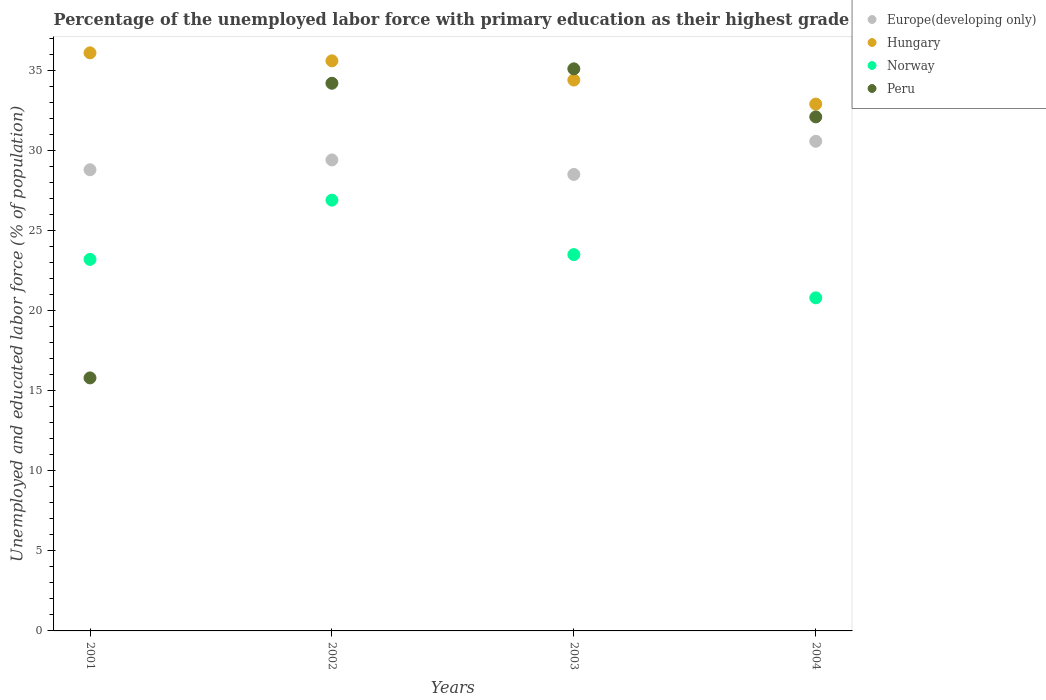What is the percentage of the unemployed labor force with primary education in Peru in 2001?
Make the answer very short. 15.8. Across all years, what is the maximum percentage of the unemployed labor force with primary education in Peru?
Offer a terse response. 35.1. Across all years, what is the minimum percentage of the unemployed labor force with primary education in Norway?
Ensure brevity in your answer.  20.8. In which year was the percentage of the unemployed labor force with primary education in Hungary maximum?
Provide a succinct answer. 2001. In which year was the percentage of the unemployed labor force with primary education in Hungary minimum?
Provide a succinct answer. 2004. What is the total percentage of the unemployed labor force with primary education in Norway in the graph?
Your response must be concise. 94.4. What is the difference between the percentage of the unemployed labor force with primary education in Europe(developing only) in 2001 and that in 2002?
Offer a very short reply. -0.61. What is the difference between the percentage of the unemployed labor force with primary education in Hungary in 2002 and the percentage of the unemployed labor force with primary education in Peru in 2003?
Ensure brevity in your answer.  0.5. What is the average percentage of the unemployed labor force with primary education in Peru per year?
Offer a terse response. 29.3. In the year 2004, what is the difference between the percentage of the unemployed labor force with primary education in Norway and percentage of the unemployed labor force with primary education in Peru?
Your response must be concise. -11.3. What is the ratio of the percentage of the unemployed labor force with primary education in Europe(developing only) in 2001 to that in 2003?
Give a very brief answer. 1.01. What is the difference between the highest and the second highest percentage of the unemployed labor force with primary education in Peru?
Your answer should be very brief. 0.9. What is the difference between the highest and the lowest percentage of the unemployed labor force with primary education in Europe(developing only)?
Offer a terse response. 2.07. Is the sum of the percentage of the unemployed labor force with primary education in Hungary in 2001 and 2003 greater than the maximum percentage of the unemployed labor force with primary education in Peru across all years?
Offer a terse response. Yes. Does the percentage of the unemployed labor force with primary education in Europe(developing only) monotonically increase over the years?
Make the answer very short. No. Is the percentage of the unemployed labor force with primary education in Norway strictly greater than the percentage of the unemployed labor force with primary education in Hungary over the years?
Ensure brevity in your answer.  No. Is the percentage of the unemployed labor force with primary education in Europe(developing only) strictly less than the percentage of the unemployed labor force with primary education in Hungary over the years?
Give a very brief answer. Yes. How many dotlines are there?
Provide a succinct answer. 4. What is the difference between two consecutive major ticks on the Y-axis?
Your response must be concise. 5. Does the graph contain grids?
Your response must be concise. No. How many legend labels are there?
Your answer should be very brief. 4. What is the title of the graph?
Your response must be concise. Percentage of the unemployed labor force with primary education as their highest grade. What is the label or title of the X-axis?
Provide a short and direct response. Years. What is the label or title of the Y-axis?
Your answer should be very brief. Unemployed and educated labor force (% of population). What is the Unemployed and educated labor force (% of population) in Europe(developing only) in 2001?
Offer a terse response. 28.8. What is the Unemployed and educated labor force (% of population) of Hungary in 2001?
Ensure brevity in your answer.  36.1. What is the Unemployed and educated labor force (% of population) in Norway in 2001?
Offer a very short reply. 23.2. What is the Unemployed and educated labor force (% of population) in Peru in 2001?
Give a very brief answer. 15.8. What is the Unemployed and educated labor force (% of population) of Europe(developing only) in 2002?
Provide a succinct answer. 29.41. What is the Unemployed and educated labor force (% of population) of Hungary in 2002?
Provide a succinct answer. 35.6. What is the Unemployed and educated labor force (% of population) in Norway in 2002?
Keep it short and to the point. 26.9. What is the Unemployed and educated labor force (% of population) in Peru in 2002?
Offer a very short reply. 34.2. What is the Unemployed and educated labor force (% of population) in Europe(developing only) in 2003?
Keep it short and to the point. 28.51. What is the Unemployed and educated labor force (% of population) of Hungary in 2003?
Keep it short and to the point. 34.4. What is the Unemployed and educated labor force (% of population) in Norway in 2003?
Provide a succinct answer. 23.5. What is the Unemployed and educated labor force (% of population) of Peru in 2003?
Offer a terse response. 35.1. What is the Unemployed and educated labor force (% of population) in Europe(developing only) in 2004?
Make the answer very short. 30.58. What is the Unemployed and educated labor force (% of population) in Hungary in 2004?
Your answer should be very brief. 32.9. What is the Unemployed and educated labor force (% of population) in Norway in 2004?
Ensure brevity in your answer.  20.8. What is the Unemployed and educated labor force (% of population) of Peru in 2004?
Give a very brief answer. 32.1. Across all years, what is the maximum Unemployed and educated labor force (% of population) in Europe(developing only)?
Offer a very short reply. 30.58. Across all years, what is the maximum Unemployed and educated labor force (% of population) of Hungary?
Ensure brevity in your answer.  36.1. Across all years, what is the maximum Unemployed and educated labor force (% of population) in Norway?
Your answer should be compact. 26.9. Across all years, what is the maximum Unemployed and educated labor force (% of population) in Peru?
Offer a very short reply. 35.1. Across all years, what is the minimum Unemployed and educated labor force (% of population) in Europe(developing only)?
Your answer should be very brief. 28.51. Across all years, what is the minimum Unemployed and educated labor force (% of population) of Hungary?
Offer a very short reply. 32.9. Across all years, what is the minimum Unemployed and educated labor force (% of population) in Norway?
Ensure brevity in your answer.  20.8. Across all years, what is the minimum Unemployed and educated labor force (% of population) of Peru?
Your response must be concise. 15.8. What is the total Unemployed and educated labor force (% of population) of Europe(developing only) in the graph?
Your response must be concise. 117.29. What is the total Unemployed and educated labor force (% of population) in Hungary in the graph?
Provide a succinct answer. 139. What is the total Unemployed and educated labor force (% of population) of Norway in the graph?
Offer a very short reply. 94.4. What is the total Unemployed and educated labor force (% of population) of Peru in the graph?
Give a very brief answer. 117.2. What is the difference between the Unemployed and educated labor force (% of population) in Europe(developing only) in 2001 and that in 2002?
Provide a succinct answer. -0.61. What is the difference between the Unemployed and educated labor force (% of population) of Hungary in 2001 and that in 2002?
Your response must be concise. 0.5. What is the difference between the Unemployed and educated labor force (% of population) in Norway in 2001 and that in 2002?
Keep it short and to the point. -3.7. What is the difference between the Unemployed and educated labor force (% of population) of Peru in 2001 and that in 2002?
Make the answer very short. -18.4. What is the difference between the Unemployed and educated labor force (% of population) of Europe(developing only) in 2001 and that in 2003?
Your answer should be very brief. 0.29. What is the difference between the Unemployed and educated labor force (% of population) of Hungary in 2001 and that in 2003?
Keep it short and to the point. 1.7. What is the difference between the Unemployed and educated labor force (% of population) of Peru in 2001 and that in 2003?
Offer a terse response. -19.3. What is the difference between the Unemployed and educated labor force (% of population) in Europe(developing only) in 2001 and that in 2004?
Your answer should be compact. -1.78. What is the difference between the Unemployed and educated labor force (% of population) of Hungary in 2001 and that in 2004?
Provide a short and direct response. 3.2. What is the difference between the Unemployed and educated labor force (% of population) of Norway in 2001 and that in 2004?
Your response must be concise. 2.4. What is the difference between the Unemployed and educated labor force (% of population) of Peru in 2001 and that in 2004?
Give a very brief answer. -16.3. What is the difference between the Unemployed and educated labor force (% of population) of Europe(developing only) in 2002 and that in 2003?
Provide a short and direct response. 0.91. What is the difference between the Unemployed and educated labor force (% of population) of Norway in 2002 and that in 2003?
Provide a succinct answer. 3.4. What is the difference between the Unemployed and educated labor force (% of population) in Europe(developing only) in 2002 and that in 2004?
Keep it short and to the point. -1.16. What is the difference between the Unemployed and educated labor force (% of population) of Hungary in 2002 and that in 2004?
Provide a short and direct response. 2.7. What is the difference between the Unemployed and educated labor force (% of population) in Norway in 2002 and that in 2004?
Offer a terse response. 6.1. What is the difference between the Unemployed and educated labor force (% of population) in Peru in 2002 and that in 2004?
Offer a very short reply. 2.1. What is the difference between the Unemployed and educated labor force (% of population) in Europe(developing only) in 2003 and that in 2004?
Give a very brief answer. -2.07. What is the difference between the Unemployed and educated labor force (% of population) of Hungary in 2003 and that in 2004?
Give a very brief answer. 1.5. What is the difference between the Unemployed and educated labor force (% of population) of Peru in 2003 and that in 2004?
Keep it short and to the point. 3. What is the difference between the Unemployed and educated labor force (% of population) in Europe(developing only) in 2001 and the Unemployed and educated labor force (% of population) in Hungary in 2002?
Offer a very short reply. -6.8. What is the difference between the Unemployed and educated labor force (% of population) of Europe(developing only) in 2001 and the Unemployed and educated labor force (% of population) of Norway in 2002?
Ensure brevity in your answer.  1.9. What is the difference between the Unemployed and educated labor force (% of population) of Europe(developing only) in 2001 and the Unemployed and educated labor force (% of population) of Peru in 2002?
Make the answer very short. -5.4. What is the difference between the Unemployed and educated labor force (% of population) of Hungary in 2001 and the Unemployed and educated labor force (% of population) of Norway in 2002?
Keep it short and to the point. 9.2. What is the difference between the Unemployed and educated labor force (% of population) of Europe(developing only) in 2001 and the Unemployed and educated labor force (% of population) of Hungary in 2003?
Ensure brevity in your answer.  -5.6. What is the difference between the Unemployed and educated labor force (% of population) in Europe(developing only) in 2001 and the Unemployed and educated labor force (% of population) in Norway in 2003?
Keep it short and to the point. 5.3. What is the difference between the Unemployed and educated labor force (% of population) in Europe(developing only) in 2001 and the Unemployed and educated labor force (% of population) in Peru in 2003?
Your answer should be very brief. -6.3. What is the difference between the Unemployed and educated labor force (% of population) of Hungary in 2001 and the Unemployed and educated labor force (% of population) of Peru in 2003?
Make the answer very short. 1. What is the difference between the Unemployed and educated labor force (% of population) of Europe(developing only) in 2001 and the Unemployed and educated labor force (% of population) of Hungary in 2004?
Give a very brief answer. -4.1. What is the difference between the Unemployed and educated labor force (% of population) in Europe(developing only) in 2001 and the Unemployed and educated labor force (% of population) in Norway in 2004?
Keep it short and to the point. 8. What is the difference between the Unemployed and educated labor force (% of population) in Europe(developing only) in 2001 and the Unemployed and educated labor force (% of population) in Peru in 2004?
Your answer should be compact. -3.3. What is the difference between the Unemployed and educated labor force (% of population) in Norway in 2001 and the Unemployed and educated labor force (% of population) in Peru in 2004?
Your answer should be very brief. -8.9. What is the difference between the Unemployed and educated labor force (% of population) in Europe(developing only) in 2002 and the Unemployed and educated labor force (% of population) in Hungary in 2003?
Offer a terse response. -4.99. What is the difference between the Unemployed and educated labor force (% of population) in Europe(developing only) in 2002 and the Unemployed and educated labor force (% of population) in Norway in 2003?
Offer a very short reply. 5.91. What is the difference between the Unemployed and educated labor force (% of population) of Europe(developing only) in 2002 and the Unemployed and educated labor force (% of population) of Peru in 2003?
Provide a succinct answer. -5.69. What is the difference between the Unemployed and educated labor force (% of population) of Hungary in 2002 and the Unemployed and educated labor force (% of population) of Norway in 2003?
Your response must be concise. 12.1. What is the difference between the Unemployed and educated labor force (% of population) in Hungary in 2002 and the Unemployed and educated labor force (% of population) in Peru in 2003?
Provide a succinct answer. 0.5. What is the difference between the Unemployed and educated labor force (% of population) in Norway in 2002 and the Unemployed and educated labor force (% of population) in Peru in 2003?
Offer a terse response. -8.2. What is the difference between the Unemployed and educated labor force (% of population) of Europe(developing only) in 2002 and the Unemployed and educated labor force (% of population) of Hungary in 2004?
Your response must be concise. -3.49. What is the difference between the Unemployed and educated labor force (% of population) of Europe(developing only) in 2002 and the Unemployed and educated labor force (% of population) of Norway in 2004?
Your answer should be compact. 8.61. What is the difference between the Unemployed and educated labor force (% of population) in Europe(developing only) in 2002 and the Unemployed and educated labor force (% of population) in Peru in 2004?
Provide a succinct answer. -2.69. What is the difference between the Unemployed and educated labor force (% of population) of Hungary in 2002 and the Unemployed and educated labor force (% of population) of Peru in 2004?
Offer a very short reply. 3.5. What is the difference between the Unemployed and educated labor force (% of population) of Norway in 2002 and the Unemployed and educated labor force (% of population) of Peru in 2004?
Provide a succinct answer. -5.2. What is the difference between the Unemployed and educated labor force (% of population) of Europe(developing only) in 2003 and the Unemployed and educated labor force (% of population) of Hungary in 2004?
Make the answer very short. -4.39. What is the difference between the Unemployed and educated labor force (% of population) of Europe(developing only) in 2003 and the Unemployed and educated labor force (% of population) of Norway in 2004?
Keep it short and to the point. 7.71. What is the difference between the Unemployed and educated labor force (% of population) in Europe(developing only) in 2003 and the Unemployed and educated labor force (% of population) in Peru in 2004?
Keep it short and to the point. -3.59. What is the difference between the Unemployed and educated labor force (% of population) in Hungary in 2003 and the Unemployed and educated labor force (% of population) in Norway in 2004?
Offer a very short reply. 13.6. What is the average Unemployed and educated labor force (% of population) of Europe(developing only) per year?
Your answer should be compact. 29.32. What is the average Unemployed and educated labor force (% of population) of Hungary per year?
Ensure brevity in your answer.  34.75. What is the average Unemployed and educated labor force (% of population) of Norway per year?
Keep it short and to the point. 23.6. What is the average Unemployed and educated labor force (% of population) of Peru per year?
Give a very brief answer. 29.3. In the year 2001, what is the difference between the Unemployed and educated labor force (% of population) in Europe(developing only) and Unemployed and educated labor force (% of population) in Hungary?
Provide a succinct answer. -7.3. In the year 2001, what is the difference between the Unemployed and educated labor force (% of population) in Europe(developing only) and Unemployed and educated labor force (% of population) in Norway?
Offer a terse response. 5.6. In the year 2001, what is the difference between the Unemployed and educated labor force (% of population) of Europe(developing only) and Unemployed and educated labor force (% of population) of Peru?
Provide a short and direct response. 13. In the year 2001, what is the difference between the Unemployed and educated labor force (% of population) of Hungary and Unemployed and educated labor force (% of population) of Peru?
Provide a short and direct response. 20.3. In the year 2001, what is the difference between the Unemployed and educated labor force (% of population) of Norway and Unemployed and educated labor force (% of population) of Peru?
Provide a succinct answer. 7.4. In the year 2002, what is the difference between the Unemployed and educated labor force (% of population) of Europe(developing only) and Unemployed and educated labor force (% of population) of Hungary?
Provide a short and direct response. -6.19. In the year 2002, what is the difference between the Unemployed and educated labor force (% of population) of Europe(developing only) and Unemployed and educated labor force (% of population) of Norway?
Give a very brief answer. 2.51. In the year 2002, what is the difference between the Unemployed and educated labor force (% of population) in Europe(developing only) and Unemployed and educated labor force (% of population) in Peru?
Your answer should be compact. -4.79. In the year 2002, what is the difference between the Unemployed and educated labor force (% of population) in Hungary and Unemployed and educated labor force (% of population) in Peru?
Keep it short and to the point. 1.4. In the year 2002, what is the difference between the Unemployed and educated labor force (% of population) of Norway and Unemployed and educated labor force (% of population) of Peru?
Your response must be concise. -7.3. In the year 2003, what is the difference between the Unemployed and educated labor force (% of population) of Europe(developing only) and Unemployed and educated labor force (% of population) of Hungary?
Your response must be concise. -5.89. In the year 2003, what is the difference between the Unemployed and educated labor force (% of population) of Europe(developing only) and Unemployed and educated labor force (% of population) of Norway?
Your response must be concise. 5.01. In the year 2003, what is the difference between the Unemployed and educated labor force (% of population) in Europe(developing only) and Unemployed and educated labor force (% of population) in Peru?
Your answer should be compact. -6.59. In the year 2003, what is the difference between the Unemployed and educated labor force (% of population) of Hungary and Unemployed and educated labor force (% of population) of Norway?
Offer a very short reply. 10.9. In the year 2004, what is the difference between the Unemployed and educated labor force (% of population) of Europe(developing only) and Unemployed and educated labor force (% of population) of Hungary?
Your response must be concise. -2.32. In the year 2004, what is the difference between the Unemployed and educated labor force (% of population) in Europe(developing only) and Unemployed and educated labor force (% of population) in Norway?
Provide a short and direct response. 9.78. In the year 2004, what is the difference between the Unemployed and educated labor force (% of population) in Europe(developing only) and Unemployed and educated labor force (% of population) in Peru?
Make the answer very short. -1.52. In the year 2004, what is the difference between the Unemployed and educated labor force (% of population) in Hungary and Unemployed and educated labor force (% of population) in Norway?
Provide a short and direct response. 12.1. In the year 2004, what is the difference between the Unemployed and educated labor force (% of population) of Hungary and Unemployed and educated labor force (% of population) of Peru?
Ensure brevity in your answer.  0.8. In the year 2004, what is the difference between the Unemployed and educated labor force (% of population) in Norway and Unemployed and educated labor force (% of population) in Peru?
Your answer should be compact. -11.3. What is the ratio of the Unemployed and educated labor force (% of population) in Europe(developing only) in 2001 to that in 2002?
Give a very brief answer. 0.98. What is the ratio of the Unemployed and educated labor force (% of population) in Norway in 2001 to that in 2002?
Ensure brevity in your answer.  0.86. What is the ratio of the Unemployed and educated labor force (% of population) of Peru in 2001 to that in 2002?
Give a very brief answer. 0.46. What is the ratio of the Unemployed and educated labor force (% of population) of Europe(developing only) in 2001 to that in 2003?
Provide a short and direct response. 1.01. What is the ratio of the Unemployed and educated labor force (% of population) in Hungary in 2001 to that in 2003?
Give a very brief answer. 1.05. What is the ratio of the Unemployed and educated labor force (% of population) in Norway in 2001 to that in 2003?
Keep it short and to the point. 0.99. What is the ratio of the Unemployed and educated labor force (% of population) of Peru in 2001 to that in 2003?
Your response must be concise. 0.45. What is the ratio of the Unemployed and educated labor force (% of population) in Europe(developing only) in 2001 to that in 2004?
Ensure brevity in your answer.  0.94. What is the ratio of the Unemployed and educated labor force (% of population) in Hungary in 2001 to that in 2004?
Ensure brevity in your answer.  1.1. What is the ratio of the Unemployed and educated labor force (% of population) in Norway in 2001 to that in 2004?
Ensure brevity in your answer.  1.12. What is the ratio of the Unemployed and educated labor force (% of population) in Peru in 2001 to that in 2004?
Ensure brevity in your answer.  0.49. What is the ratio of the Unemployed and educated labor force (% of population) in Europe(developing only) in 2002 to that in 2003?
Your answer should be very brief. 1.03. What is the ratio of the Unemployed and educated labor force (% of population) of Hungary in 2002 to that in 2003?
Your answer should be compact. 1.03. What is the ratio of the Unemployed and educated labor force (% of population) of Norway in 2002 to that in 2003?
Offer a terse response. 1.14. What is the ratio of the Unemployed and educated labor force (% of population) of Peru in 2002 to that in 2003?
Keep it short and to the point. 0.97. What is the ratio of the Unemployed and educated labor force (% of population) of Europe(developing only) in 2002 to that in 2004?
Provide a succinct answer. 0.96. What is the ratio of the Unemployed and educated labor force (% of population) of Hungary in 2002 to that in 2004?
Make the answer very short. 1.08. What is the ratio of the Unemployed and educated labor force (% of population) of Norway in 2002 to that in 2004?
Keep it short and to the point. 1.29. What is the ratio of the Unemployed and educated labor force (% of population) of Peru in 2002 to that in 2004?
Your response must be concise. 1.07. What is the ratio of the Unemployed and educated labor force (% of population) in Europe(developing only) in 2003 to that in 2004?
Keep it short and to the point. 0.93. What is the ratio of the Unemployed and educated labor force (% of population) in Hungary in 2003 to that in 2004?
Offer a very short reply. 1.05. What is the ratio of the Unemployed and educated labor force (% of population) in Norway in 2003 to that in 2004?
Provide a short and direct response. 1.13. What is the ratio of the Unemployed and educated labor force (% of population) in Peru in 2003 to that in 2004?
Provide a succinct answer. 1.09. What is the difference between the highest and the second highest Unemployed and educated labor force (% of population) in Europe(developing only)?
Your response must be concise. 1.16. What is the difference between the highest and the second highest Unemployed and educated labor force (% of population) of Hungary?
Provide a succinct answer. 0.5. What is the difference between the highest and the second highest Unemployed and educated labor force (% of population) of Peru?
Offer a very short reply. 0.9. What is the difference between the highest and the lowest Unemployed and educated labor force (% of population) in Europe(developing only)?
Your response must be concise. 2.07. What is the difference between the highest and the lowest Unemployed and educated labor force (% of population) of Hungary?
Offer a very short reply. 3.2. What is the difference between the highest and the lowest Unemployed and educated labor force (% of population) of Norway?
Your answer should be very brief. 6.1. What is the difference between the highest and the lowest Unemployed and educated labor force (% of population) in Peru?
Your answer should be compact. 19.3. 